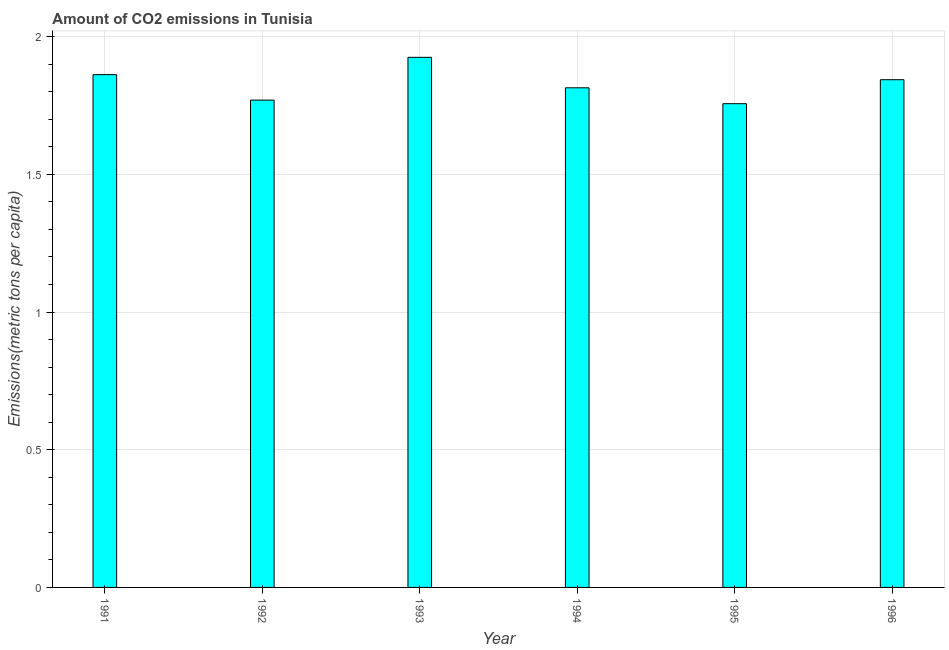Does the graph contain any zero values?
Offer a very short reply. No. Does the graph contain grids?
Keep it short and to the point. Yes. What is the title of the graph?
Your response must be concise. Amount of CO2 emissions in Tunisia. What is the label or title of the Y-axis?
Your response must be concise. Emissions(metric tons per capita). What is the amount of co2 emissions in 1993?
Your answer should be very brief. 1.93. Across all years, what is the maximum amount of co2 emissions?
Ensure brevity in your answer.  1.93. Across all years, what is the minimum amount of co2 emissions?
Ensure brevity in your answer.  1.76. In which year was the amount of co2 emissions maximum?
Provide a succinct answer. 1993. In which year was the amount of co2 emissions minimum?
Provide a short and direct response. 1995. What is the sum of the amount of co2 emissions?
Offer a terse response. 10.97. What is the difference between the amount of co2 emissions in 1994 and 1996?
Offer a terse response. -0.03. What is the average amount of co2 emissions per year?
Your answer should be very brief. 1.83. What is the median amount of co2 emissions?
Keep it short and to the point. 1.83. Do a majority of the years between 1994 and 1996 (inclusive) have amount of co2 emissions greater than 0.9 metric tons per capita?
Your response must be concise. Yes. What is the difference between the highest and the second highest amount of co2 emissions?
Your response must be concise. 0.06. Is the sum of the amount of co2 emissions in 1994 and 1996 greater than the maximum amount of co2 emissions across all years?
Provide a succinct answer. Yes. What is the difference between the highest and the lowest amount of co2 emissions?
Provide a short and direct response. 0.17. In how many years, is the amount of co2 emissions greater than the average amount of co2 emissions taken over all years?
Give a very brief answer. 3. Are all the bars in the graph horizontal?
Your answer should be compact. No. What is the difference between two consecutive major ticks on the Y-axis?
Make the answer very short. 0.5. What is the Emissions(metric tons per capita) in 1991?
Make the answer very short. 1.86. What is the Emissions(metric tons per capita) in 1992?
Provide a succinct answer. 1.77. What is the Emissions(metric tons per capita) in 1993?
Make the answer very short. 1.93. What is the Emissions(metric tons per capita) in 1994?
Provide a short and direct response. 1.81. What is the Emissions(metric tons per capita) in 1995?
Keep it short and to the point. 1.76. What is the Emissions(metric tons per capita) of 1996?
Make the answer very short. 1.84. What is the difference between the Emissions(metric tons per capita) in 1991 and 1992?
Offer a terse response. 0.09. What is the difference between the Emissions(metric tons per capita) in 1991 and 1993?
Make the answer very short. -0.06. What is the difference between the Emissions(metric tons per capita) in 1991 and 1994?
Your answer should be compact. 0.05. What is the difference between the Emissions(metric tons per capita) in 1991 and 1995?
Your answer should be compact. 0.11. What is the difference between the Emissions(metric tons per capita) in 1991 and 1996?
Keep it short and to the point. 0.02. What is the difference between the Emissions(metric tons per capita) in 1992 and 1993?
Provide a short and direct response. -0.16. What is the difference between the Emissions(metric tons per capita) in 1992 and 1994?
Provide a short and direct response. -0.04. What is the difference between the Emissions(metric tons per capita) in 1992 and 1995?
Keep it short and to the point. 0.01. What is the difference between the Emissions(metric tons per capita) in 1992 and 1996?
Offer a terse response. -0.07. What is the difference between the Emissions(metric tons per capita) in 1993 and 1994?
Your response must be concise. 0.11. What is the difference between the Emissions(metric tons per capita) in 1993 and 1995?
Offer a terse response. 0.17. What is the difference between the Emissions(metric tons per capita) in 1993 and 1996?
Provide a succinct answer. 0.08. What is the difference between the Emissions(metric tons per capita) in 1994 and 1995?
Your answer should be very brief. 0.06. What is the difference between the Emissions(metric tons per capita) in 1994 and 1996?
Your response must be concise. -0.03. What is the difference between the Emissions(metric tons per capita) in 1995 and 1996?
Provide a short and direct response. -0.09. What is the ratio of the Emissions(metric tons per capita) in 1991 to that in 1992?
Make the answer very short. 1.05. What is the ratio of the Emissions(metric tons per capita) in 1991 to that in 1993?
Provide a short and direct response. 0.97. What is the ratio of the Emissions(metric tons per capita) in 1991 to that in 1994?
Make the answer very short. 1.03. What is the ratio of the Emissions(metric tons per capita) in 1991 to that in 1995?
Offer a very short reply. 1.06. What is the ratio of the Emissions(metric tons per capita) in 1991 to that in 1996?
Your response must be concise. 1.01. What is the ratio of the Emissions(metric tons per capita) in 1992 to that in 1993?
Your response must be concise. 0.92. What is the ratio of the Emissions(metric tons per capita) in 1992 to that in 1996?
Your answer should be very brief. 0.96. What is the ratio of the Emissions(metric tons per capita) in 1993 to that in 1994?
Your response must be concise. 1.06. What is the ratio of the Emissions(metric tons per capita) in 1993 to that in 1995?
Keep it short and to the point. 1.1. What is the ratio of the Emissions(metric tons per capita) in 1993 to that in 1996?
Your answer should be very brief. 1.04. What is the ratio of the Emissions(metric tons per capita) in 1994 to that in 1995?
Your answer should be compact. 1.03. What is the ratio of the Emissions(metric tons per capita) in 1995 to that in 1996?
Provide a succinct answer. 0.95. 